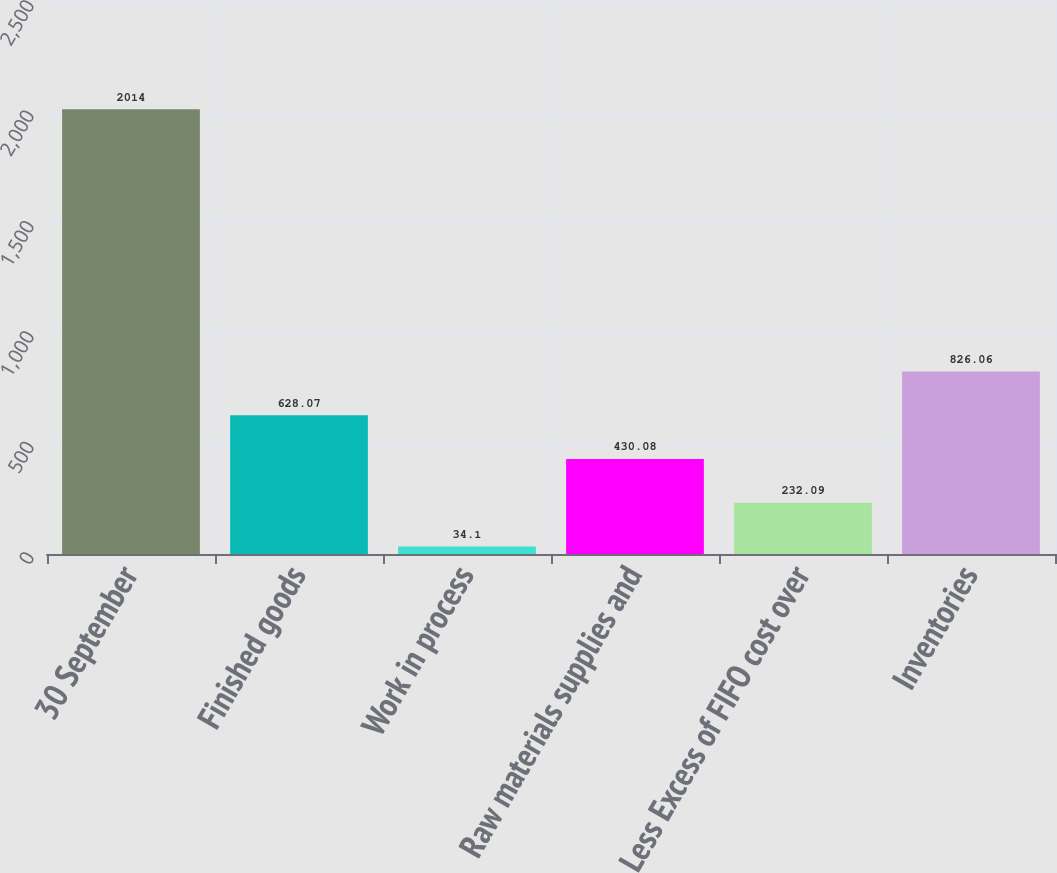Convert chart to OTSL. <chart><loc_0><loc_0><loc_500><loc_500><bar_chart><fcel>30 September<fcel>Finished goods<fcel>Work in process<fcel>Raw materials supplies and<fcel>Less Excess of FIFO cost over<fcel>Inventories<nl><fcel>2014<fcel>628.07<fcel>34.1<fcel>430.08<fcel>232.09<fcel>826.06<nl></chart> 